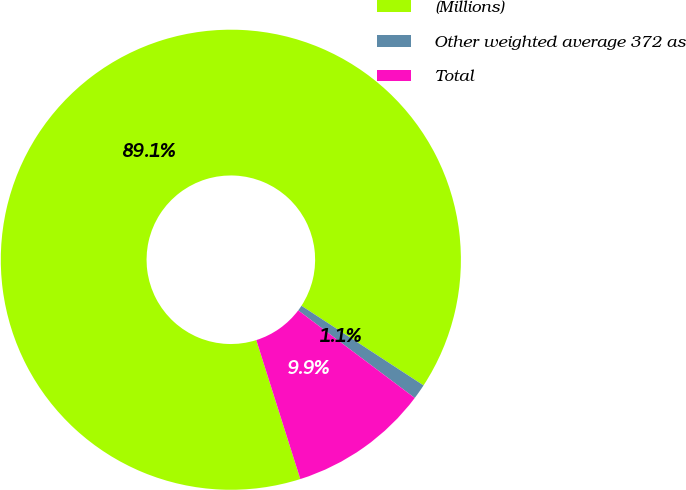Convert chart to OTSL. <chart><loc_0><loc_0><loc_500><loc_500><pie_chart><fcel>(Millions)<fcel>Other weighted average 372 as<fcel>Total<nl><fcel>89.07%<fcel>1.06%<fcel>9.86%<nl></chart> 